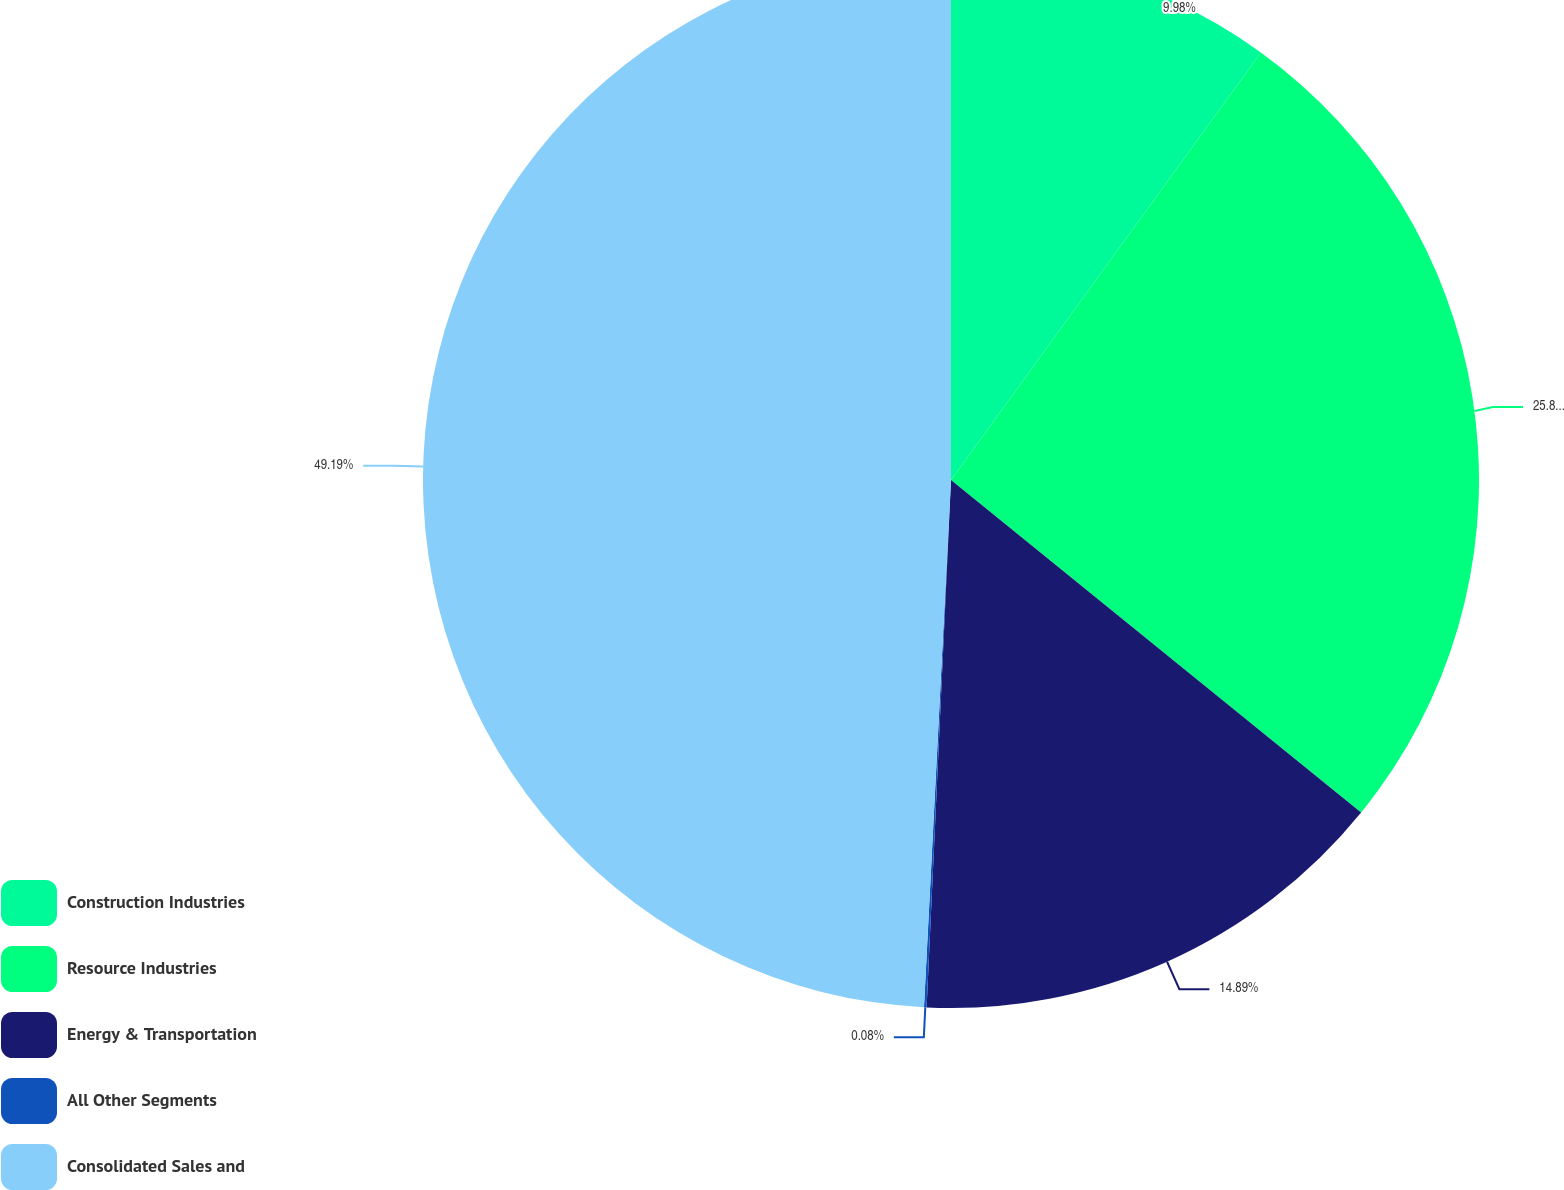<chart> <loc_0><loc_0><loc_500><loc_500><pie_chart><fcel>Construction Industries<fcel>Resource Industries<fcel>Energy & Transportation<fcel>All Other Segments<fcel>Consolidated Sales and<nl><fcel>9.98%<fcel>25.86%<fcel>14.89%<fcel>0.08%<fcel>49.18%<nl></chart> 